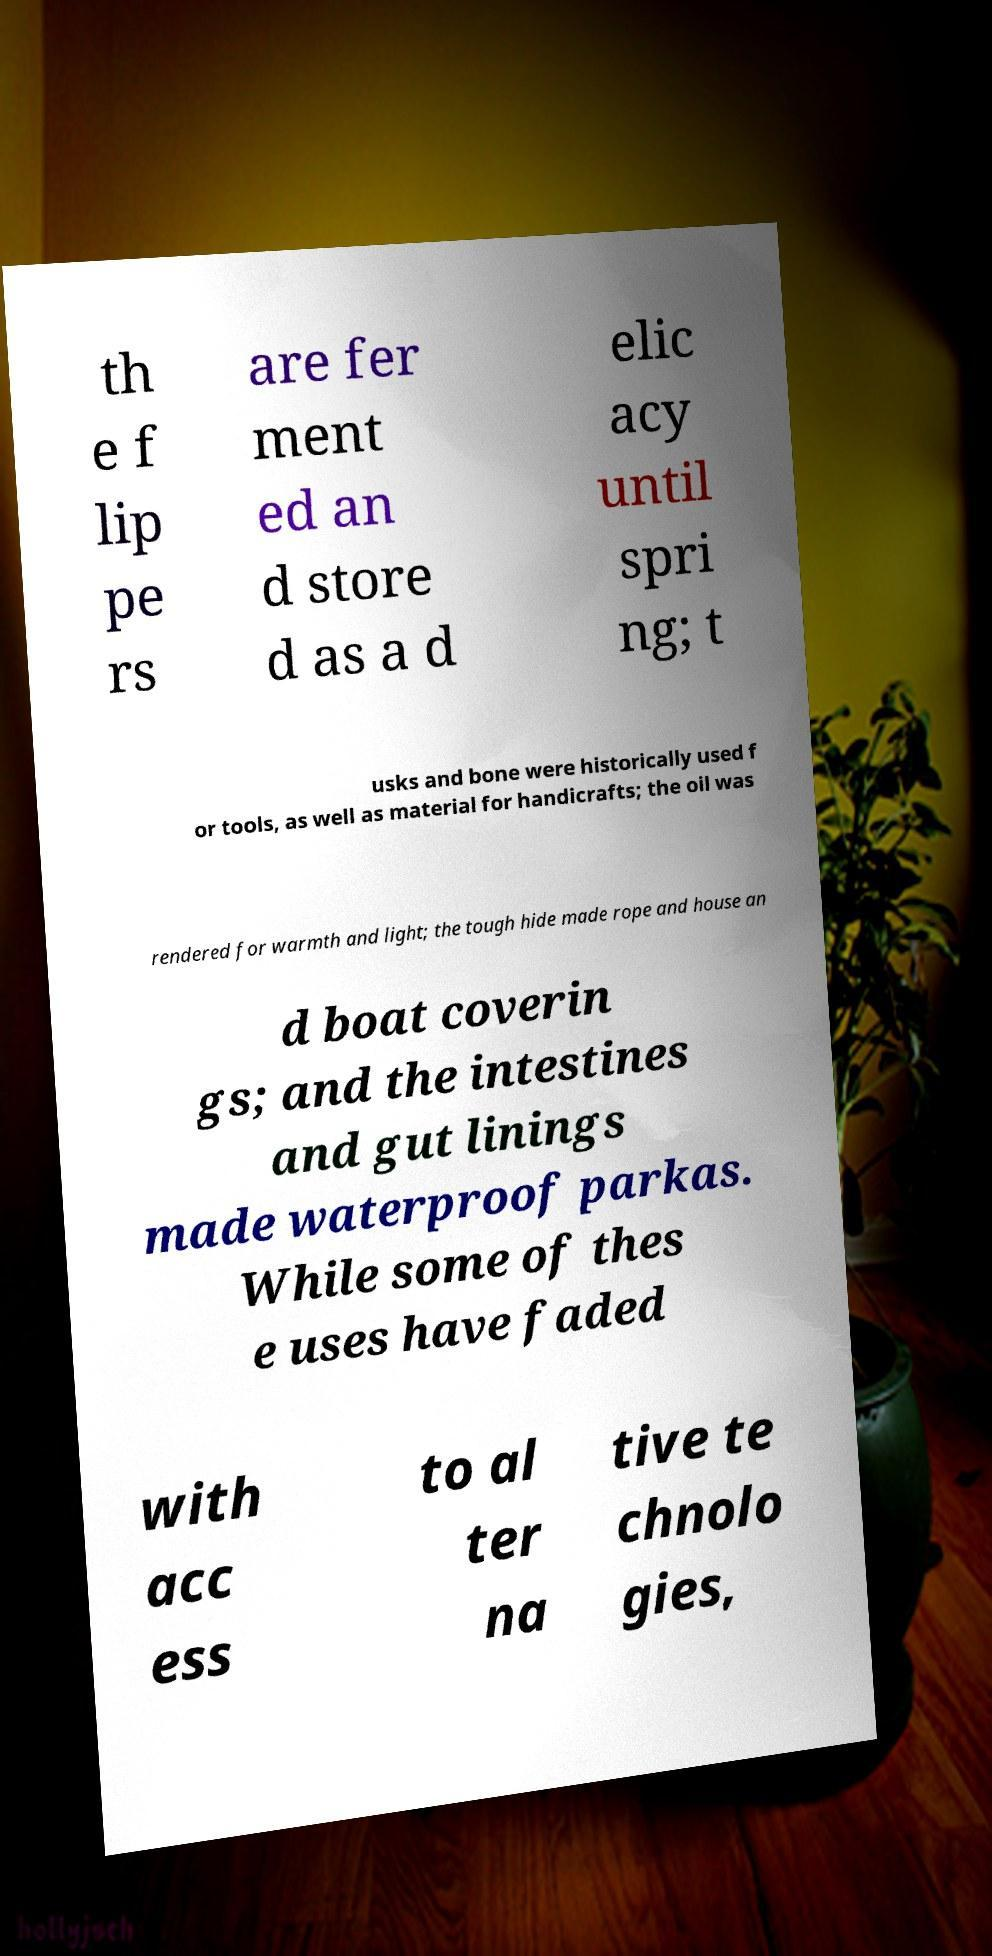Can you accurately transcribe the text from the provided image for me? th e f lip pe rs are fer ment ed an d store d as a d elic acy until spri ng; t usks and bone were historically used f or tools, as well as material for handicrafts; the oil was rendered for warmth and light; the tough hide made rope and house an d boat coverin gs; and the intestines and gut linings made waterproof parkas. While some of thes e uses have faded with acc ess to al ter na tive te chnolo gies, 